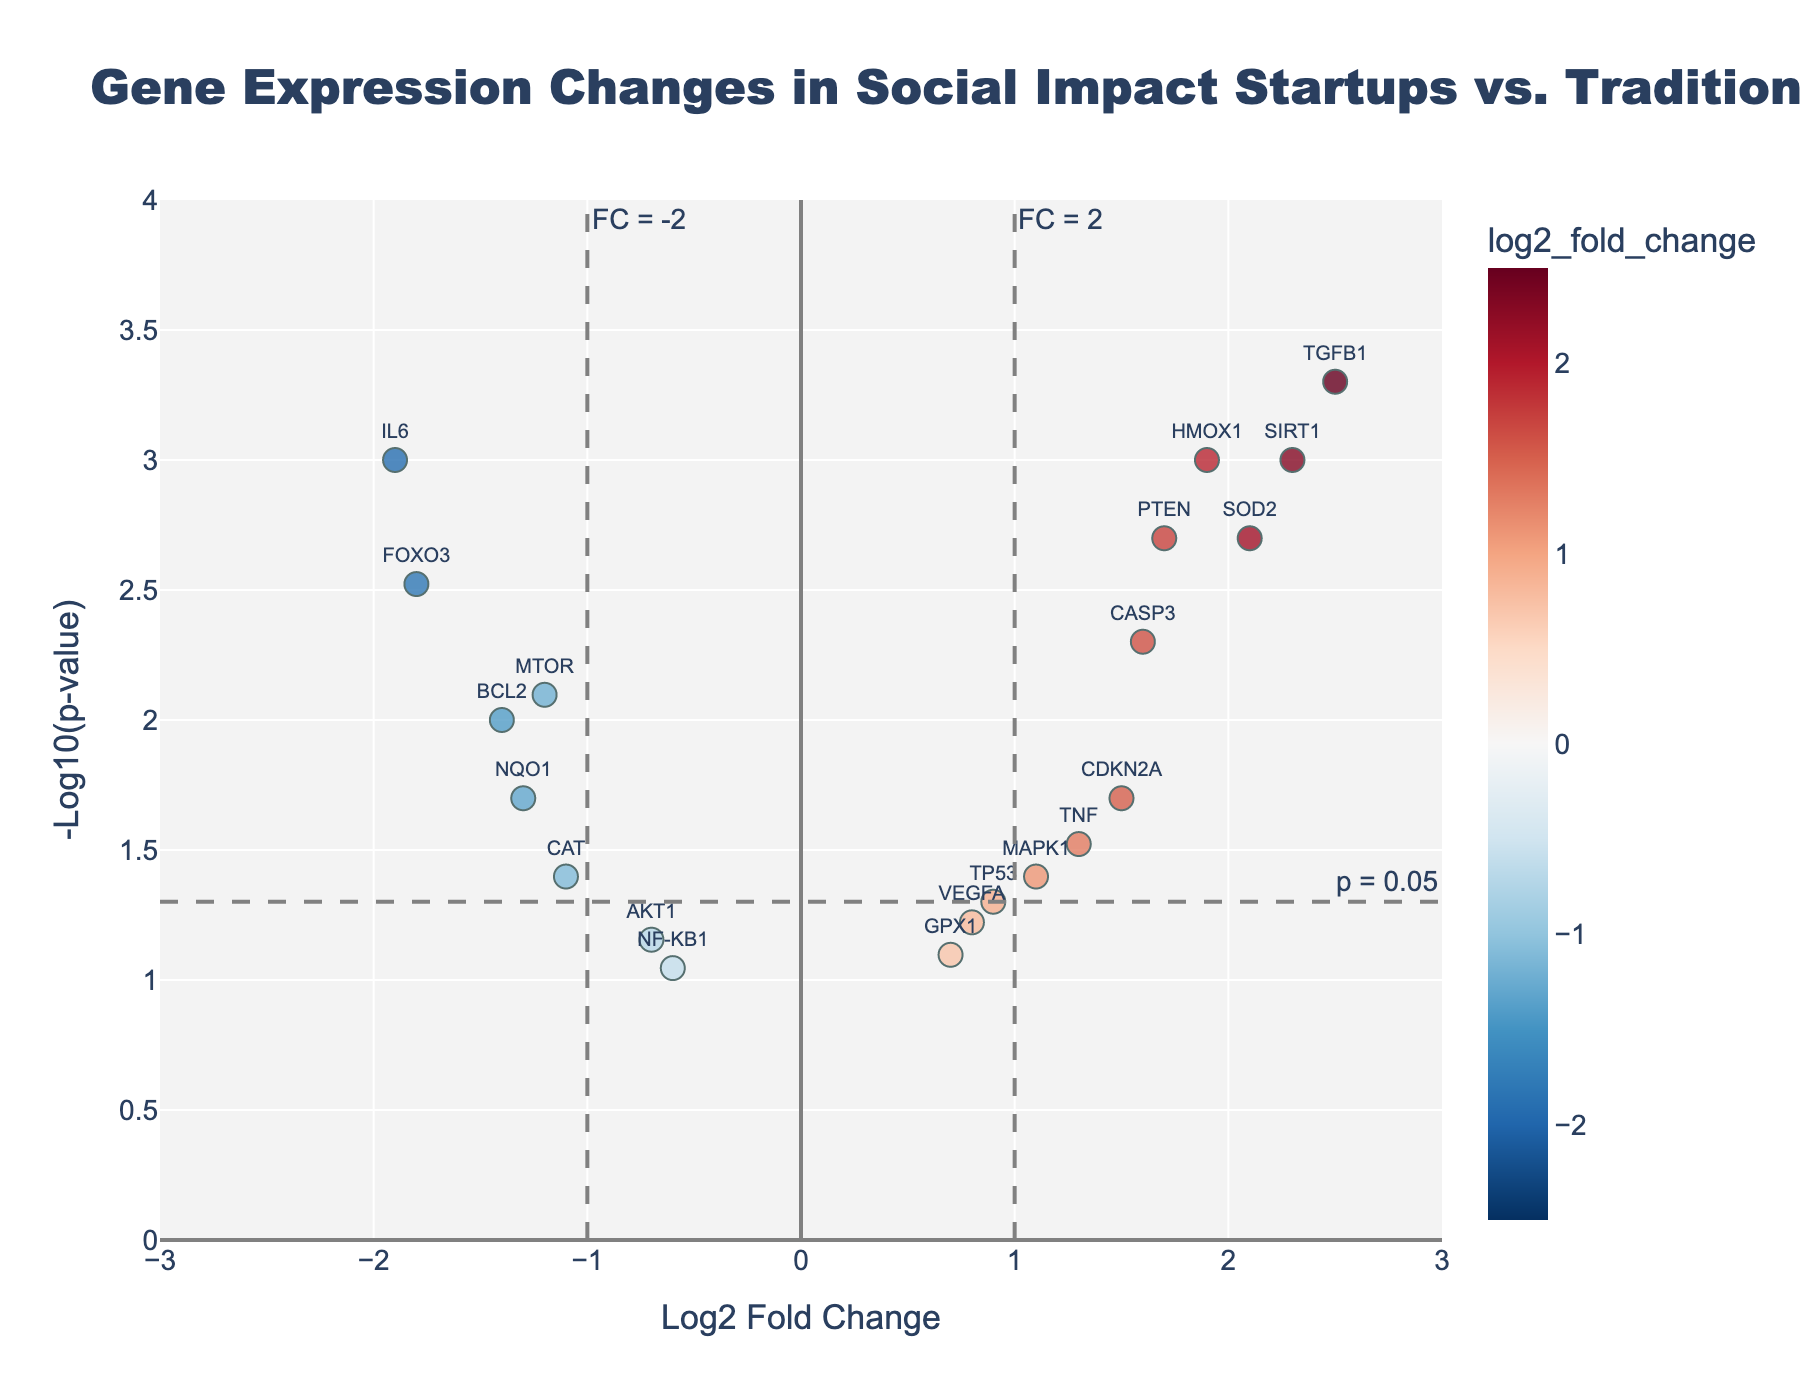What's the title of the figure? The title of a plot is usually displayed at the top. In this case, the title "Gene Expression Changes in Social Impact Startups vs. Traditional Businesses" is centered at the top of the plot. This information directly tells the viewer what the plot is about.
Answer: Gene Expression Changes in Social Impact Startups vs. Traditional Businesses How is the X-axis labeled? The X-axis label is displayed along the horizontal axis of the plot. According to the rendered Volcano Plot, the X-axis is labeled as "Log2 Fold Change," indicating the gene expression changes as a log base 2 value.
Answer: Log2 Fold Change Where are the most statistically significant gene changes, according to the Y-axis? The Y-axis represents the -Log10(p-value). The higher the value on the Y-axis, the more statistically significant the gene changes. Genes at the top of the plot (with the highest Y-values) are the most statistically significant.
Answer: At the top Which gene has the highest Log2 Fold Change? By inspecting the values on the X-axis, the gene with the highest positive value for Log2 Fold Change can be determined. In this case, TGFB1 has the highest Log2 Fold Change around 2.5.
Answer: TGFB1 Which gene has the most statistically significant down-regulation? For a gene to be down-regulated, its Log2 Fold Change must be negative. The gene with the lowest p-value (highest -Log10(p-value)) among those with negative Log2 Fold Change is IL6.
Answer: IL6 How does the quantity of differentially expressed genes with p < 0.05 compare to those with p ≥ 0.05? To determine this, count the number of data points above the horizontal significance threshold of y = -log10(0.05) and compare it to those below this threshold.
Answer: More with p < 0.05 What are the significance cutoffs on the plot? Significance cutoffs are typically indicated by dashed lines. In this plot, there's a horizontal line at -log10(0.05) for the p-value, and vertical lines at Log2 Fold Change of -2 and 2.
Answer: -log10(0.05) for p-value, Log2 Fold Change of -2 and 2 What's the Log2 Fold Change threshold for differential regulation? The vertical dashed lines signify this threshold, indicating that a Log2 Fold Change of -2 or 2 is used as a cutoff for significant gene expression changes.
Answer: -2 and 2 Between SIRT1 and CDKN2A, which gene is more statistically significant and why? By comparing the -Log10(p-value) for both genes, SIRT1 has a higher value than CDKN2A, making it more statistically significant because a higher -Log10(p-value) corresponds to a lower p-value.
Answer: SIRT1 